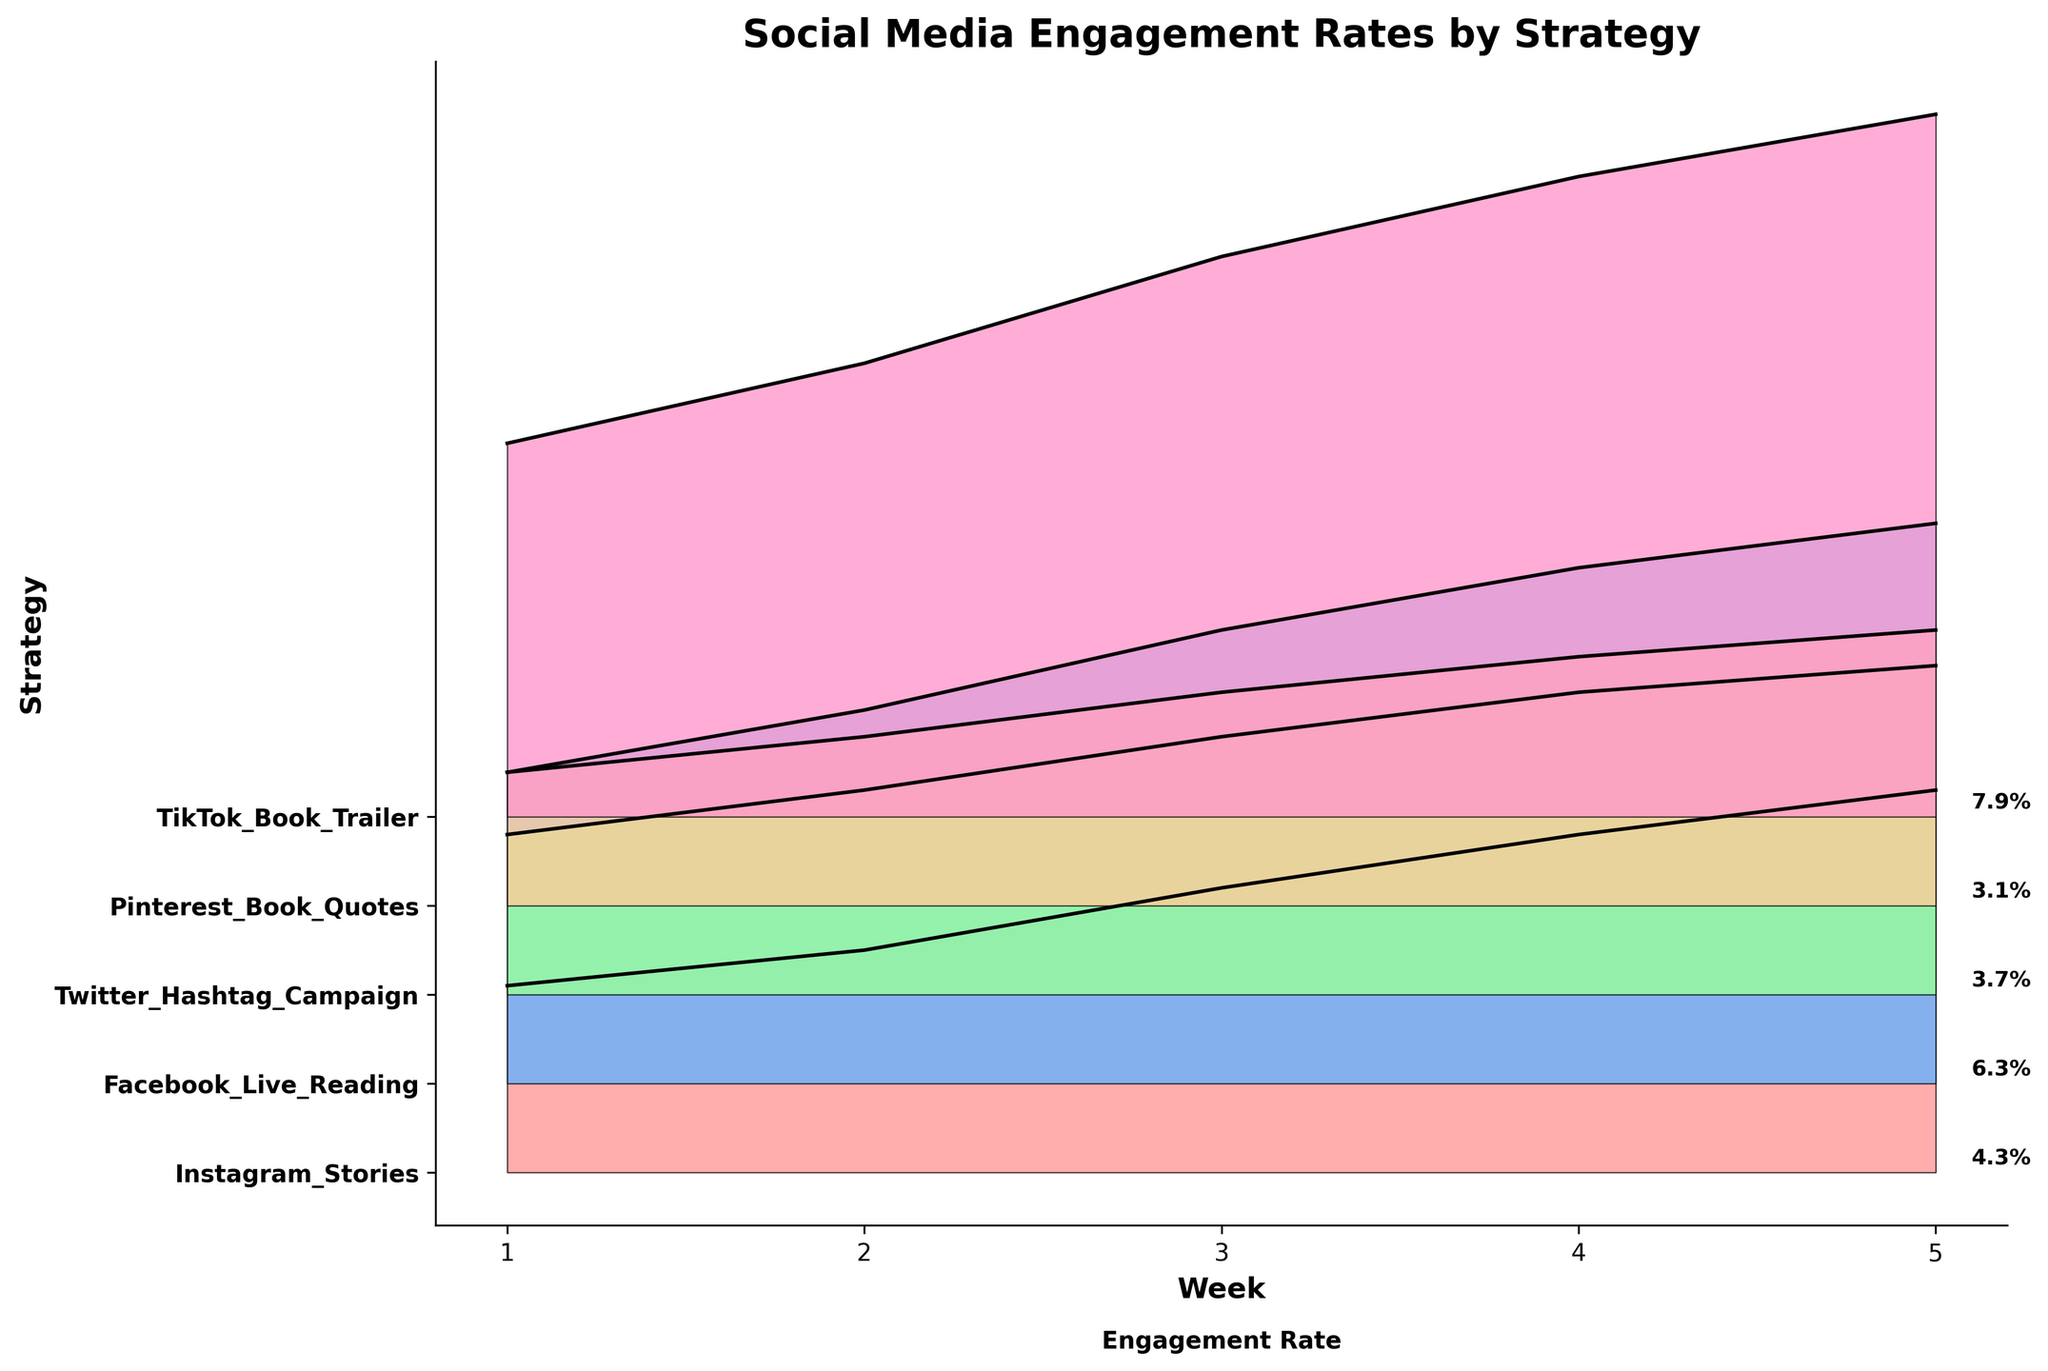What is the title of the figure? The title of the figure is the large text at the top of the chart that describes what the figure is about.
Answer: Social Media Engagement Rates by Strategy How many different book promotion strategies are presented in the figure? Count the unique labels on the y-axis, each representing a different strategy.
Answer: Five Which strategy has the highest engagement rate in Week 5? Identify the lines and filled areas for each strategy in Week 5 and find the strategy with the highest point on the y-axis.
Answer: TikTok Book Trailer What is the engagement rate of Pinterest Book Quotes in Week 3? Locate the Pinterest Book Quotes curve and find the corresponding engagement rate at Week 3 on the x-axis.
Answer: 2.4% Between Weeks 2 and 3, which strategy shows the largest increase in engagement rate? Calculate the differences in engagement rates between Weeks 2 and 3 for each strategy, and identify the largest one.
Answer: Facebook Live Reading How does the engagement rate for Instagram Stories change over the weeks? Track the points on the Instagram Stories line from Week 1 to Week 5 and describe the trend.
Answer: Increasing Which strategy shows the least engagement rate in Week 1? Compare the engagement rates for all strategies at Week 1 and find the smallest one.
Answer: Pinterest Book Quotes What is the average engagement rate for Twitter Hashtag Campaign over the entire period? Sum up the engagement rates for Twitter Hashtag Campaign from Week 1 to Week 5 and divide by the number of weeks.
Answer: (1.8 + 2.3 + 2.9 + 3.4 + 3.7) / 5 = 2.82% Which strategy has the steepest rise in engagement rates over the 5-week period? Compare the slopes of the lines representing each strategy from Week 1 to Week 5.
Answer: TikTok Book Trailer Order the strategies from highest to lowest engagement rate at the end of the campaign. Look at the engagement rates for each strategy at Week 5 and list them in descending order.
Answer: TikTok Book Trailer, Facebook Live Reading, Instagram Stories, Twitter Hashtag Campaign, Pinterest Book Quotes 